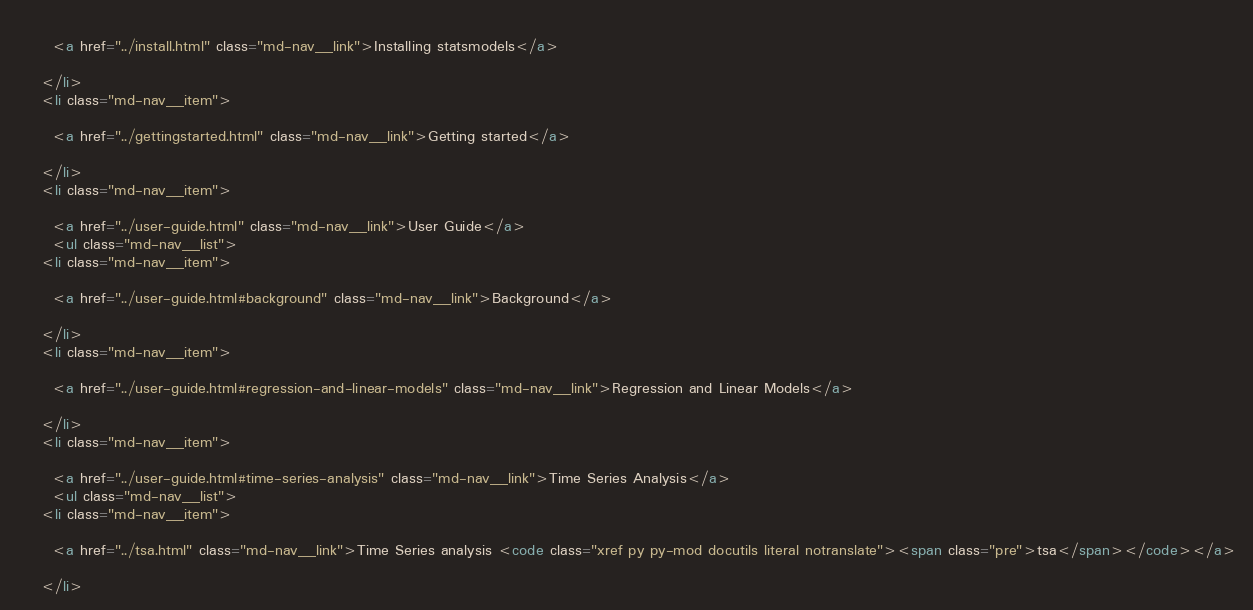<code> <loc_0><loc_0><loc_500><loc_500><_HTML_>    
      <a href="../install.html" class="md-nav__link">Installing statsmodels</a>
      
    </li>
    <li class="md-nav__item">
    
      <a href="../gettingstarted.html" class="md-nav__link">Getting started</a>
      
    </li>
    <li class="md-nav__item">
    
      <a href="../user-guide.html" class="md-nav__link">User Guide</a>
      <ul class="md-nav__list"> 
    <li class="md-nav__item">
    
      <a href="../user-guide.html#background" class="md-nav__link">Background</a>
      
    </li>
    <li class="md-nav__item">
    
      <a href="../user-guide.html#regression-and-linear-models" class="md-nav__link">Regression and Linear Models</a>
      
    </li>
    <li class="md-nav__item">
    
      <a href="../user-guide.html#time-series-analysis" class="md-nav__link">Time Series Analysis</a>
      <ul class="md-nav__list"> 
    <li class="md-nav__item">
    
      <a href="../tsa.html" class="md-nav__link">Time Series analysis <code class="xref py py-mod docutils literal notranslate"><span class="pre">tsa</span></code></a>
      
    </li></code> 